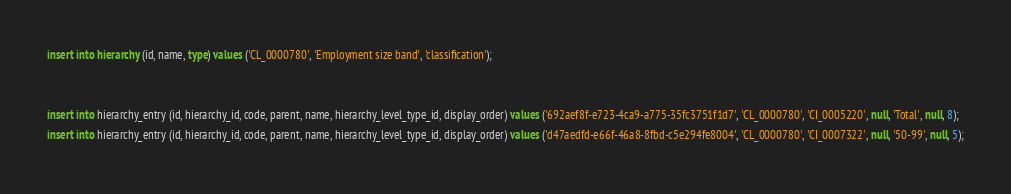<code> <loc_0><loc_0><loc_500><loc_500><_SQL_>insert into hierarchy (id, name, type) values ('CL_0000780', 'Employment size band', 'classification');


insert into hierarchy_entry (id, hierarchy_id, code, parent, name, hierarchy_level_type_id, display_order) values ('692aef8f-e723-4ca9-a775-35fc3751f1d7', 'CL_0000780', 'CI_0005220', null, 'Total', null, 8);
insert into hierarchy_entry (id, hierarchy_id, code, parent, name, hierarchy_level_type_id, display_order) values ('d47aedfd-e66f-46a8-8fbd-c5e294fe8004', 'CL_0000780', 'CI_0007322', null, '50-99', null, 5);</code> 